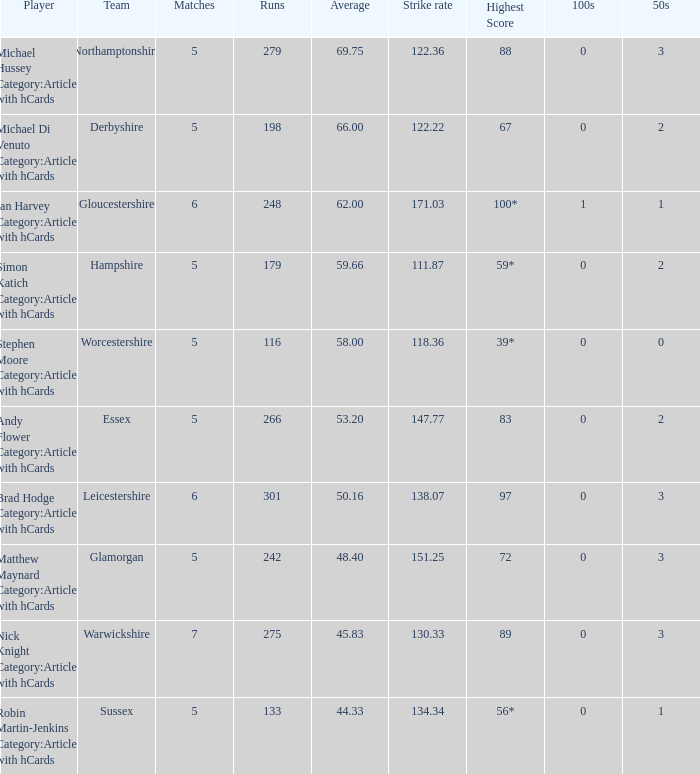16, who is the athlete? Brad Hodge Category:Articles with hCards. 